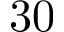Convert formula to latex. <formula><loc_0><loc_0><loc_500><loc_500>3 0</formula> 